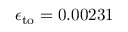Convert formula to latex. <formula><loc_0><loc_0><loc_500><loc_500>\epsilon _ { t o } = 0 . 0 0 2 3 1</formula> 